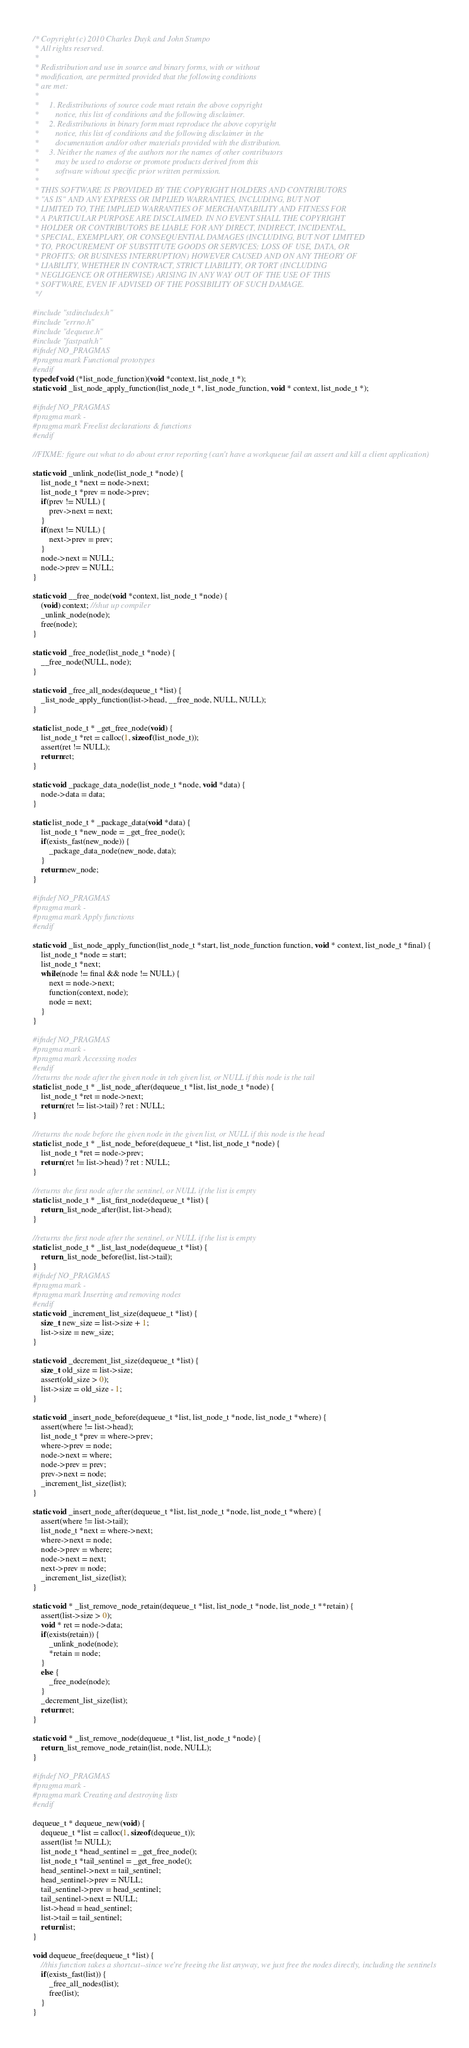Convert code to text. <code><loc_0><loc_0><loc_500><loc_500><_C_>/* Copyright (c) 2010 Charles Duyk and John Stumpo
 * All rights reserved.
 *
 * Redistribution and use in source and binary forms, with or without
 * modification, are permitted provided that the following conditions
 * are met:
 *
 *     1. Redistributions of source code must retain the above copyright
 *        notice, this list of conditions and the following disclaimer.
 *     2. Redistributions in binary form must reproduce the above copyright
 *        notice, this list of conditions and the following disclaimer in the
 *        documentation and/or other materials provided with the distribution.
 *     3. Neither the names of the authors nor the names of other contributors
 *        may be used to endorse or promote products derived from this
 *        software without specific prior written permission.
 *
 * THIS SOFTWARE IS PROVIDED BY THE COPYRIGHT HOLDERS AND CONTRIBUTORS
 * "AS IS" AND ANY EXPRESS OR IMPLIED WARRANTIES, INCLUDING, BUT NOT
 * LIMITED TO, THE IMPLIED WARRANTIES OF MERCHANTABILITY AND FITNESS FOR
 * A PARTICULAR PURPOSE ARE DISCLAIMED. IN NO EVENT SHALL THE COPYRIGHT
 * HOLDER OR CONTRIBUTORS BE LIABLE FOR ANY DIRECT, INDIRECT, INCIDENTAL,
 * SPECIAL, EXEMPLARY, OR CONSEQUENTIAL DAMAGES (INCLUDING, BUT NOT LIMITED
 * TO, PROCUREMENT OF SUBSTITUTE GOODS OR SERVICES; LOSS OF USE, DATA, OR
 * PROFITS; OR BUSINESS INTERRUPTION) HOWEVER CAUSED AND ON ANY THEORY OF
 * LIABILITY, WHETHER IN CONTRACT, STRICT LIABILITY, OR TORT (INCLUDING
 * NEGLIGENCE OR OTHERWISE) ARISING IN ANY WAY OUT OF THE USE OF THIS
 * SOFTWARE, EVEN IF ADVISED OF THE POSSIBILITY OF SUCH DAMAGE.
 */

#include "stdincludes.h"
#include "errno.h"
#include "dequeue.h"
#include "fastpath.h"
#ifndef NO_PRAGMAS
#pragma mark Functional prototypes
#endif
typedef void (*list_node_function)(void *context, list_node_t *);
static void _list_node_apply_function(list_node_t *, list_node_function, void * context, list_node_t *);

#ifndef NO_PRAGMAS
#pragma mark -
#pragma mark Freelist declarations & functions
#endif 

//FIXME: figure out what to do about error reporting (can't have a workqueue fail an assert and kill a client application)

static void _unlink_node(list_node_t *node) {
	list_node_t *next = node->next;
	list_node_t *prev = node->prev;
	if(prev != NULL) {
		prev->next = next;
	}
	if(next != NULL) {
		next->prev = prev;
	}
	node->next = NULL;
	node->prev = NULL;
}

static void __free_node(void *context, list_node_t *node) {
	(void) context; //shut up compiler
	_unlink_node(node);
	free(node);
}

static void _free_node(list_node_t *node) {
	__free_node(NULL, node);
}

static void _free_all_nodes(dequeue_t *list) {
	_list_node_apply_function(list->head, __free_node, NULL, NULL);
}

static list_node_t * _get_free_node(void) {
	list_node_t *ret = calloc(1, sizeof(list_node_t));
	assert(ret != NULL);
	return ret;
}

static void _package_data_node(list_node_t *node, void *data) {
	node->data = data;
}

static list_node_t * _package_data(void *data) {
	list_node_t *new_node = _get_free_node();
	if(exists_fast(new_node)) {
		_package_data_node(new_node, data);
	}
	return new_node;
}

#ifndef NO_PRAGMAS
#pragma mark -
#pragma mark Apply functions
#endif

static void _list_node_apply_function(list_node_t *start, list_node_function function, void * context, list_node_t *final) {
	list_node_t *node = start;
	list_node_t *next;
	while(node != final && node != NULL) {
		next = node->next;
		function(context, node);
		node = next;
	}
}

#ifndef NO_PRAGMAS
#pragma mark -
#pragma mark Accessing nodes
#endif
//returns the node after the given node in teh given list, or NULL if this node is the tail
static list_node_t * _list_node_after(dequeue_t *list, list_node_t *node) {
	list_node_t *ret = node->next;
	return (ret != list->tail) ? ret : NULL; 
}

//returns the node before the given node in the given list, or NULL if this node is the head
static list_node_t * _list_node_before(dequeue_t *list, list_node_t *node) {
	list_node_t *ret = node->prev;
	return (ret != list->head) ? ret : NULL;
}

//returns the first node after the sentinel, or NULL if the list is empty
static list_node_t * _list_first_node(dequeue_t *list) {
	return _list_node_after(list, list->head);
}

//returns the first node after the sentinel, or NULL if the list is empty
static list_node_t * _list_last_node(dequeue_t *list) {
	return _list_node_before(list, list->tail);
}
#ifndef NO_PRAGMAS
#pragma mark -
#pragma mark Inserting and removing nodes
#endif
static void _increment_list_size(dequeue_t *list) {
	size_t new_size = list->size + 1;
	list->size = new_size;
}

static void _decrement_list_size(dequeue_t *list) {
	size_t old_size = list->size;
	assert(old_size > 0);
	list->size = old_size - 1;
}

static void _insert_node_before(dequeue_t *list, list_node_t *node, list_node_t *where) {
	assert(where != list->head);
	list_node_t *prev = where->prev;
	where->prev = node;
	node->next = where;
	node->prev = prev;
	prev->next = node;
	_increment_list_size(list);
}

static void _insert_node_after(dequeue_t *list, list_node_t *node, list_node_t *where) {
	assert(where != list->tail);
	list_node_t *next = where->next;
	where->next = node;
	node->prev = where;
	node->next = next;
	next->prev = node;
	_increment_list_size(list);
}

static void * _list_remove_node_retain(dequeue_t *list, list_node_t *node, list_node_t **retain) {
	assert(list->size > 0);
	void * ret = node->data;
	if(exists(retain)) {
		_unlink_node(node);
		*retain = node;
	}
	else {
		_free_node(node);
	}
	_decrement_list_size(list);
	return ret;
}

static void * _list_remove_node(dequeue_t *list, list_node_t *node) {
	return _list_remove_node_retain(list, node, NULL);
}

#ifndef NO_PRAGMAS
#pragma mark -
#pragma mark Creating and destroying lists
#endif

dequeue_t * dequeue_new(void) {
	dequeue_t *list = calloc(1, sizeof(dequeue_t));
	assert(list != NULL);
	list_node_t *head_sentinel = _get_free_node();
	list_node_t *tail_sentinel = _get_free_node();
	head_sentinel->next = tail_sentinel;
	head_sentinel->prev = NULL;
	tail_sentinel->prev = head_sentinel;
	tail_sentinel->next = NULL;
	list->head = head_sentinel;
	list->tail = tail_sentinel;
	return list;
}

void dequeue_free(dequeue_t *list) {
	//this function takes a shortcut--since we're freeing the list anyway, we just free the nodes directly, including the sentinels
	if(exists_fast(list)) {
		_free_all_nodes(list);
		free(list);
	}
}
</code> 